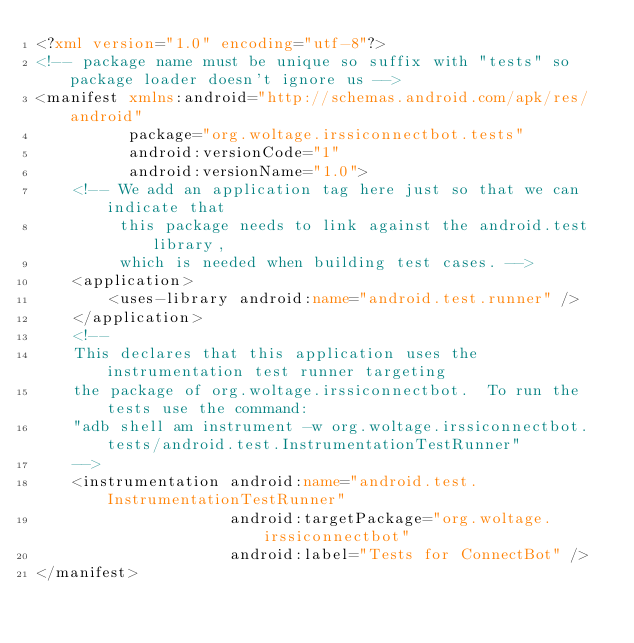<code> <loc_0><loc_0><loc_500><loc_500><_XML_><?xml version="1.0" encoding="utf-8"?>
<!-- package name must be unique so suffix with "tests" so package loader doesn't ignore us -->
<manifest xmlns:android="http://schemas.android.com/apk/res/android"
          package="org.woltage.irssiconnectbot.tests"
          android:versionCode="1"
          android:versionName="1.0">
    <!-- We add an application tag here just so that we can indicate that
         this package needs to link against the android.test library,
         which is needed when building test cases. -->
    <application>
        <uses-library android:name="android.test.runner" />
    </application>
    <!--
    This declares that this application uses the instrumentation test runner targeting
    the package of org.woltage.irssiconnectbot.  To run the tests use the command:
    "adb shell am instrument -w org.woltage.irssiconnectbot.tests/android.test.InstrumentationTestRunner"
    -->
    <instrumentation android:name="android.test.InstrumentationTestRunner"
                     android:targetPackage="org.woltage.irssiconnectbot"
                     android:label="Tests for ConnectBot" />
</manifest>
</code> 